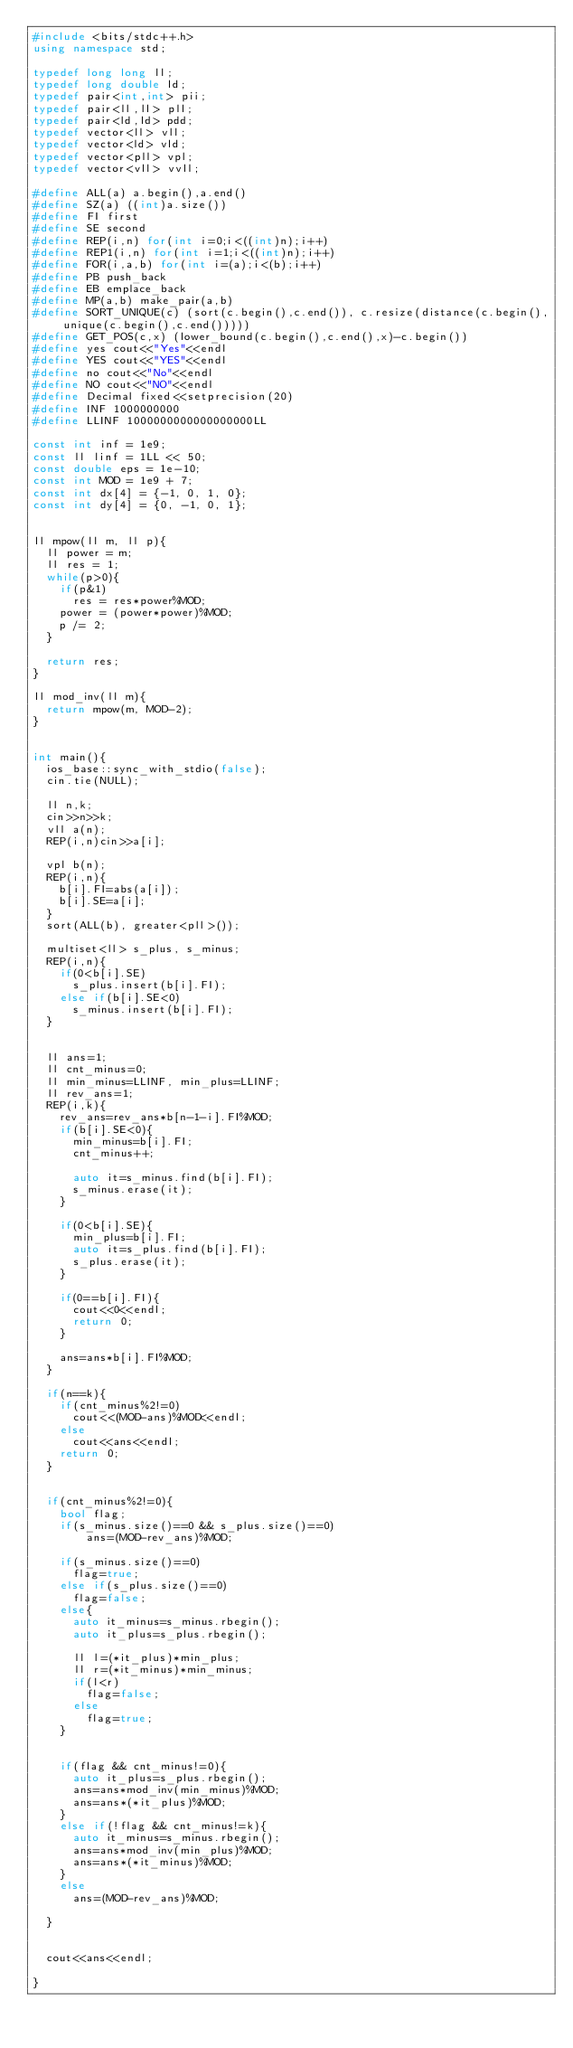<code> <loc_0><loc_0><loc_500><loc_500><_C++_>#include <bits/stdc++.h>
using namespace std;

typedef long long ll;
typedef long double ld;
typedef pair<int,int> pii;
typedef pair<ll,ll> pll;
typedef pair<ld,ld> pdd;
typedef vector<ll> vll;
typedef vector<ld> vld;
typedef vector<pll> vpl;
typedef vector<vll> vvll;

#define ALL(a) a.begin(),a.end()
#define SZ(a) ((int)a.size())
#define FI first
#define SE second
#define REP(i,n) for(int i=0;i<((int)n);i++)
#define REP1(i,n) for(int i=1;i<((int)n);i++)
#define FOR(i,a,b) for(int i=(a);i<(b);i++)
#define PB push_back
#define EB emplace_back
#define MP(a,b) make_pair(a,b)
#define SORT_UNIQUE(c) (sort(c.begin(),c.end()), c.resize(distance(c.begin(),unique(c.begin(),c.end()))))
#define GET_POS(c,x) (lower_bound(c.begin(),c.end(),x)-c.begin())
#define yes cout<<"Yes"<<endl
#define YES cout<<"YES"<<endl
#define no cout<<"No"<<endl
#define NO cout<<"NO"<<endl
#define Decimal fixed<<setprecision(20)
#define INF 1000000000
#define LLINF 1000000000000000000LL

const int inf = 1e9;
const ll linf = 1LL << 50;
const double eps = 1e-10;
const int MOD = 1e9 + 7;
const int dx[4] = {-1, 0, 1, 0};
const int dy[4] = {0, -1, 0, 1};


ll mpow(ll m, ll p){
  ll power = m;
  ll res = 1;
  while(p>0){
    if(p&1)
      res = res*power%MOD;
    power = (power*power)%MOD;
    p /= 2;
  }

  return res;
}

ll mod_inv(ll m){
  return mpow(m, MOD-2);
}


int main(){
  ios_base::sync_with_stdio(false);
  cin.tie(NULL);

  ll n,k;
  cin>>n>>k;
  vll a(n);
  REP(i,n)cin>>a[i];

  vpl b(n);
  REP(i,n){
    b[i].FI=abs(a[i]);
    b[i].SE=a[i];
  }
  sort(ALL(b), greater<pll>());

  multiset<ll> s_plus, s_minus;
  REP(i,n){
    if(0<b[i].SE)
      s_plus.insert(b[i].FI);
    else if(b[i].SE<0)
      s_minus.insert(b[i].FI);
  }


  ll ans=1;
  ll cnt_minus=0;
  ll min_minus=LLINF, min_plus=LLINF;
  ll rev_ans=1;
  REP(i,k){
    rev_ans=rev_ans*b[n-1-i].FI%MOD;
    if(b[i].SE<0){
      min_minus=b[i].FI;
      cnt_minus++;

      auto it=s_minus.find(b[i].FI);
      s_minus.erase(it);
    }

    if(0<b[i].SE){
      min_plus=b[i].FI;
      auto it=s_plus.find(b[i].FI);
      s_plus.erase(it);
    }

    if(0==b[i].FI){
      cout<<0<<endl;
      return 0;
    }

    ans=ans*b[i].FI%MOD;
  }

  if(n==k){
    if(cnt_minus%2!=0)
      cout<<(MOD-ans)%MOD<<endl;
    else
      cout<<ans<<endl;
    return 0;
  }


  if(cnt_minus%2!=0){
    bool flag;
    if(s_minus.size()==0 && s_plus.size()==0)
        ans=(MOD-rev_ans)%MOD;

    if(s_minus.size()==0)
      flag=true;
    else if(s_plus.size()==0)
      flag=false;
    else{
      auto it_minus=s_minus.rbegin();
      auto it_plus=s_plus.rbegin();

      ll l=(*it_plus)*min_plus;
      ll r=(*it_minus)*min_minus;
      if(l<r)
        flag=false;
      else
        flag=true;
    }


    if(flag && cnt_minus!=0){
      auto it_plus=s_plus.rbegin();
      ans=ans*mod_inv(min_minus)%MOD;
      ans=ans*(*it_plus)%MOD;
    }
    else if(!flag && cnt_minus!=k){
      auto it_minus=s_minus.rbegin();
      ans=ans*mod_inv(min_plus)%MOD;
      ans=ans*(*it_minus)%MOD;
    }
    else
      ans=(MOD-rev_ans)%MOD;

  }


  cout<<ans<<endl;

}

</code> 